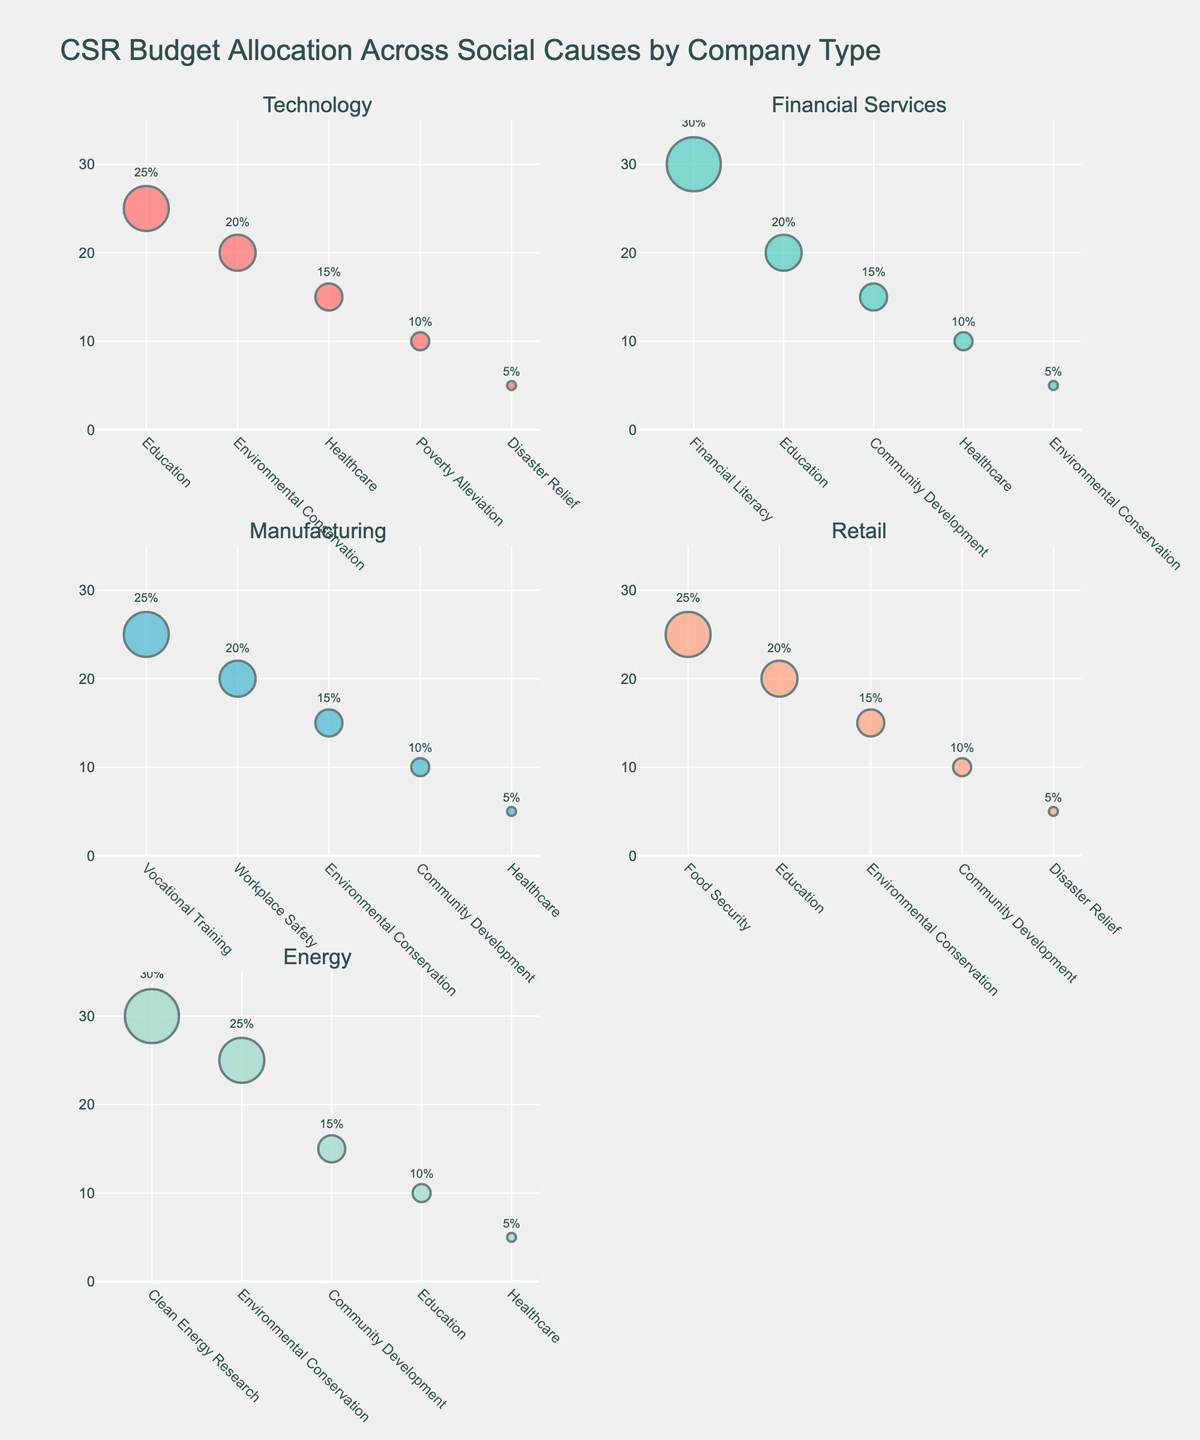What is the title of the figure? The title is usually located at the top center of the figure and specifies what the figure is about.
Answer: Etymology Trends of Mycological Terms Across Centuries Which root had the highest count in the 21st century? Look at the data points for each root in the 21st century and identify the one with the highest value.
Answer: Latin Root How many roots are being compared in the figure? Count the number of distinct lines/markers in the subplots.
Answer: 4 What is the approximate increase in the count of Greek Root terms from the 16th to the 21st century? Subtract the count of Greek Root terms in the 16th century from its count in the 21st century. Specifically, 60 - 8 = 52.
Answer: 52 Which century shows the largest increase in Latin Root terms from the previous century? Calculate the differences in Latin Root counts between consecutive centuries and find the largest one.
Answer: 19th Century Between which two centuries did French Root terms experience the smallest growth? Determine the growth between consecutive centuries for French Root terms and find the smallest change.
Answer: 16th to 17th Century Are there any centuries where Old English Root terms surpass Greek Root terms? Compare the counts of Old English Root and Greek Root for each century to see if Old English Root is ever higher.
Answer: No What is the overall trend for Old English Root terms over the centuries? Observe the direction of the line representing Old English Root across the x-axis (centuries).
Answer: Gradually Increasing In which subplot is the trend for Greek Root terms displayed? Identify which of the four subplots (based on orientation) shows the data for Greek Root terms.
Answer: Top-right Which root showed the most consistent (steady) increase over the centuries? By comparing the lines for each root, determine which one increases most smoothly without large fluctuations.
Answer: Greek Root 